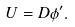<formula> <loc_0><loc_0><loc_500><loc_500>U = D \phi ^ { \prime } .</formula> 